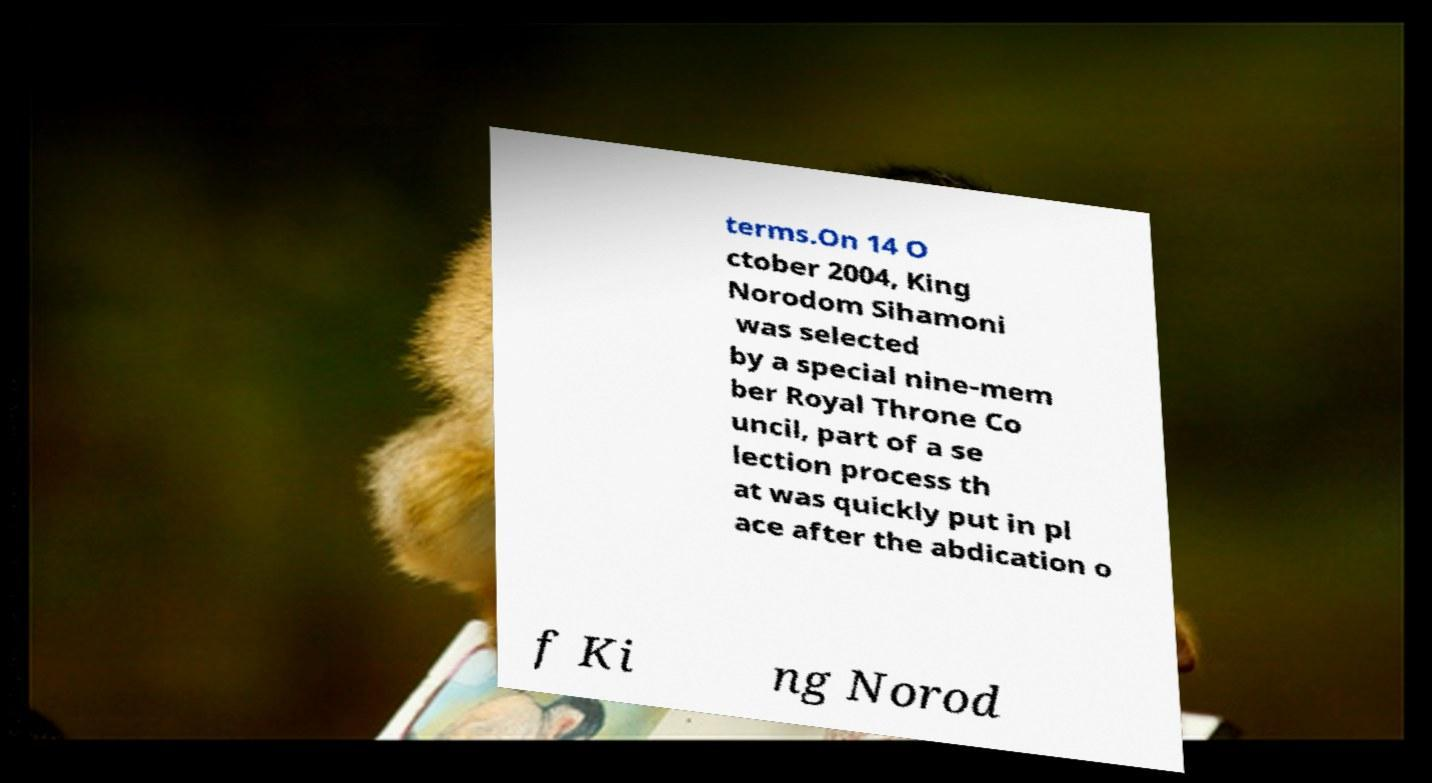Please read and relay the text visible in this image. What does it say? terms.On 14 O ctober 2004, King Norodom Sihamoni was selected by a special nine-mem ber Royal Throne Co uncil, part of a se lection process th at was quickly put in pl ace after the abdication o f Ki ng Norod 